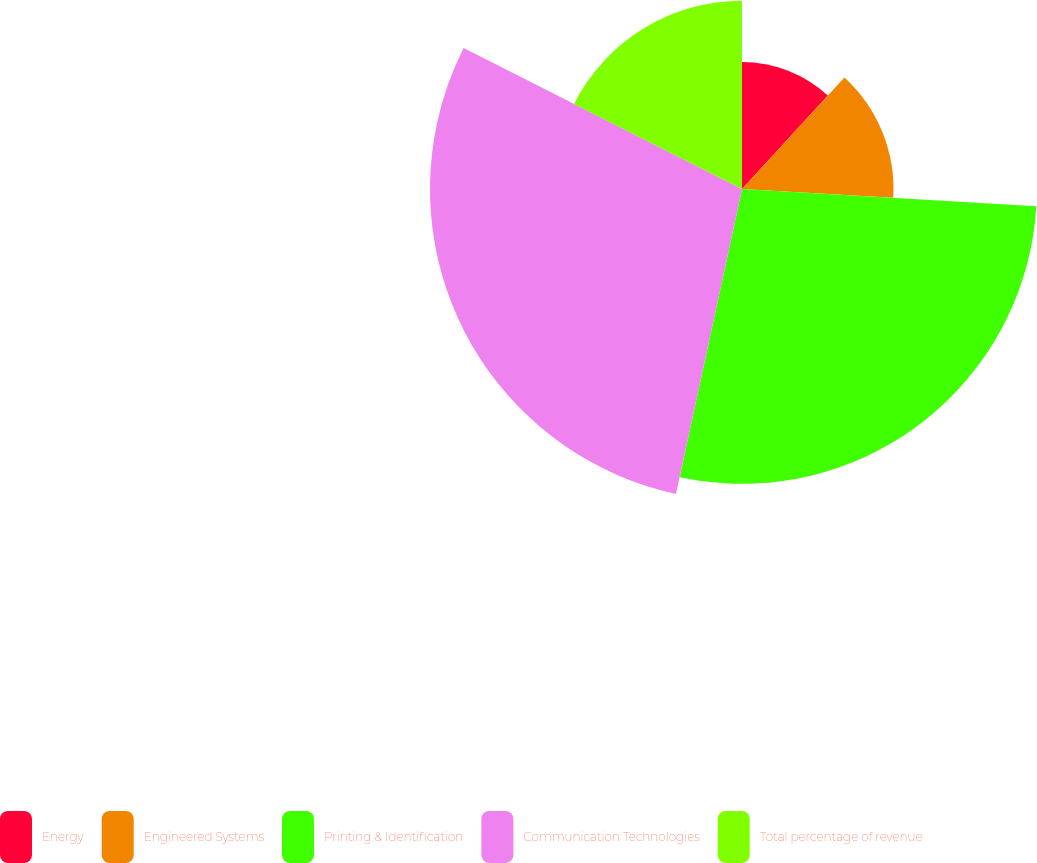<chart> <loc_0><loc_0><loc_500><loc_500><pie_chart><fcel>Energy<fcel>Engineered Systems<fcel>Printing & Identification<fcel>Communication Technologies<fcel>Total percentage of revenue<nl><fcel>11.82%<fcel>14.11%<fcel>27.46%<fcel>29.06%<fcel>17.54%<nl></chart> 